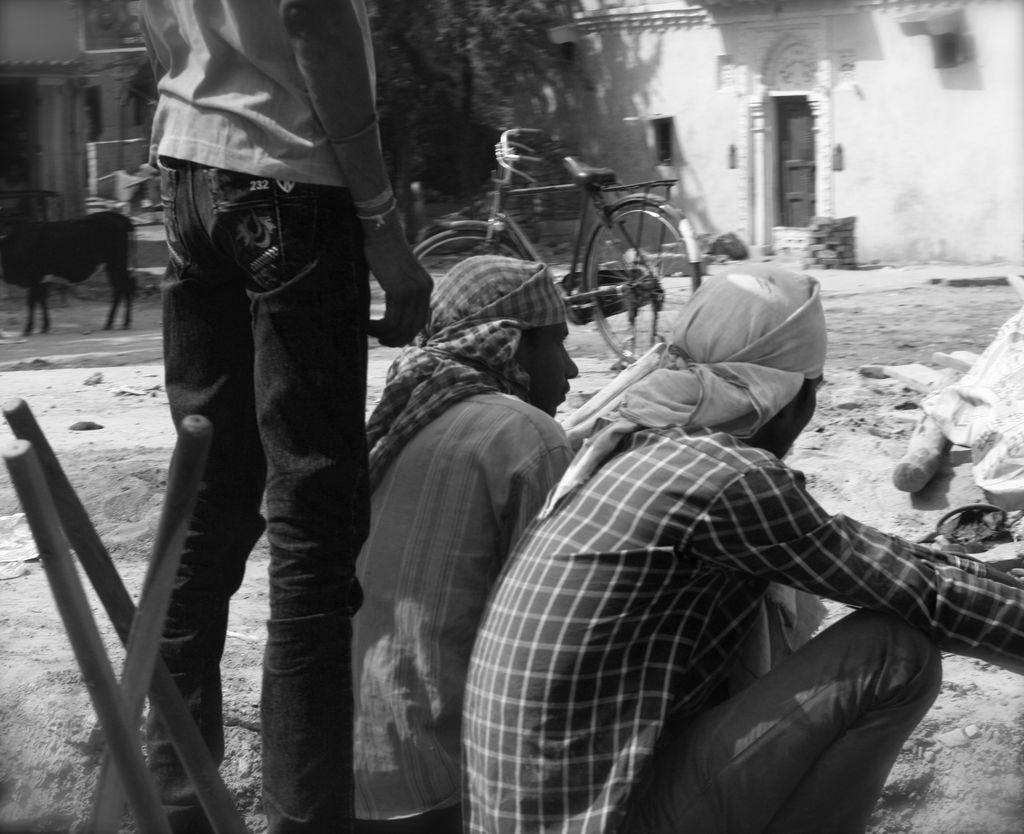Describe this image in one or two sentences. It looks like a black and white picture. We can see a man is standing and two people are in squat position. On the left side of the image there are some objects. Behind the people there is a bicycle, an animal, tree and houses. 